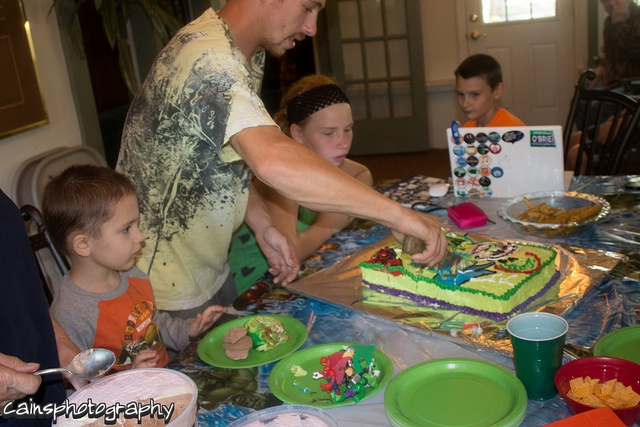Describe the objects in this image and their specific colors. I can see dining table in black, gray, darkgray, and darkgreen tones, people in black, gray, tan, and darkgray tones, people in black, gray, and brown tones, people in black, gray, and darkgray tones, and cake in black, olive, khaki, and darkgreen tones in this image. 